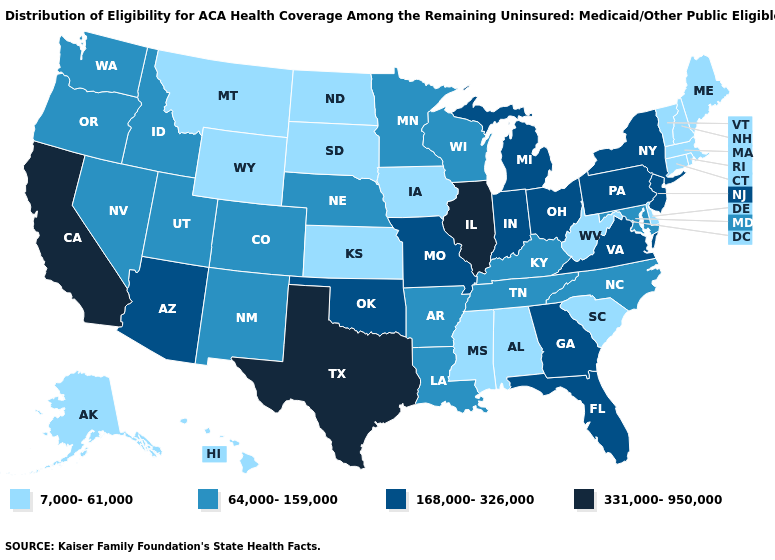Does Hawaii have the lowest value in the USA?
Short answer required. Yes. Which states hav the highest value in the Northeast?
Concise answer only. New Jersey, New York, Pennsylvania. Name the states that have a value in the range 7,000-61,000?
Quick response, please. Alabama, Alaska, Connecticut, Delaware, Hawaii, Iowa, Kansas, Maine, Massachusetts, Mississippi, Montana, New Hampshire, North Dakota, Rhode Island, South Carolina, South Dakota, Vermont, West Virginia, Wyoming. Name the states that have a value in the range 331,000-950,000?
Be succinct. California, Illinois, Texas. Does Alabama have the lowest value in the South?
Write a very short answer. Yes. What is the value of New York?
Write a very short answer. 168,000-326,000. What is the highest value in the Northeast ?
Answer briefly. 168,000-326,000. Among the states that border Texas , does Oklahoma have the highest value?
Keep it brief. Yes. Which states have the highest value in the USA?
Be succinct. California, Illinois, Texas. What is the value of Mississippi?
Give a very brief answer. 7,000-61,000. Which states have the lowest value in the USA?
Concise answer only. Alabama, Alaska, Connecticut, Delaware, Hawaii, Iowa, Kansas, Maine, Massachusetts, Mississippi, Montana, New Hampshire, North Dakota, Rhode Island, South Carolina, South Dakota, Vermont, West Virginia, Wyoming. Does Illinois have the highest value in the MidWest?
Answer briefly. Yes. Does Montana have a higher value than Wisconsin?
Concise answer only. No. Name the states that have a value in the range 7,000-61,000?
Short answer required. Alabama, Alaska, Connecticut, Delaware, Hawaii, Iowa, Kansas, Maine, Massachusetts, Mississippi, Montana, New Hampshire, North Dakota, Rhode Island, South Carolina, South Dakota, Vermont, West Virginia, Wyoming. Name the states that have a value in the range 7,000-61,000?
Keep it brief. Alabama, Alaska, Connecticut, Delaware, Hawaii, Iowa, Kansas, Maine, Massachusetts, Mississippi, Montana, New Hampshire, North Dakota, Rhode Island, South Carolina, South Dakota, Vermont, West Virginia, Wyoming. 